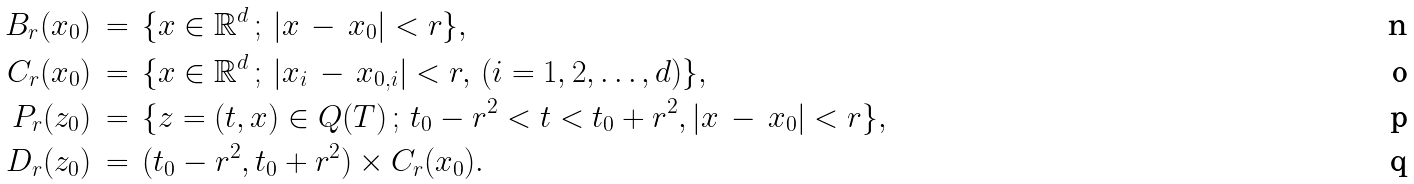Convert formula to latex. <formula><loc_0><loc_0><loc_500><loc_500>B _ { r } ( x _ { 0 } ) & \, = \, \{ x \in \mathbb { R } ^ { d } \, ; \, | x \, - \, x _ { 0 } | < r \} , \\ C _ { r } ( x _ { 0 } ) & \, = \, \{ x \in \mathbb { R } ^ { d } \, ; \, | x _ { i } \, - \, x _ { 0 , i } | < r , \, ( i = 1 , 2 , \dots , d ) \} , \\ P _ { r } ( z _ { 0 } ) & \, = \, \{ z = ( t , x ) \in Q ( T ) \, ; \, t _ { 0 } - r ^ { 2 } < t < t _ { 0 } + r ^ { 2 } , | x \, - \, x _ { 0 } | < r \} , \\ D _ { r } ( z _ { 0 } ) & \, = \, ( t _ { 0 } - r ^ { 2 } , t _ { 0 } + r ^ { 2 } ) \times C _ { r } ( x _ { 0 } ) .</formula> 